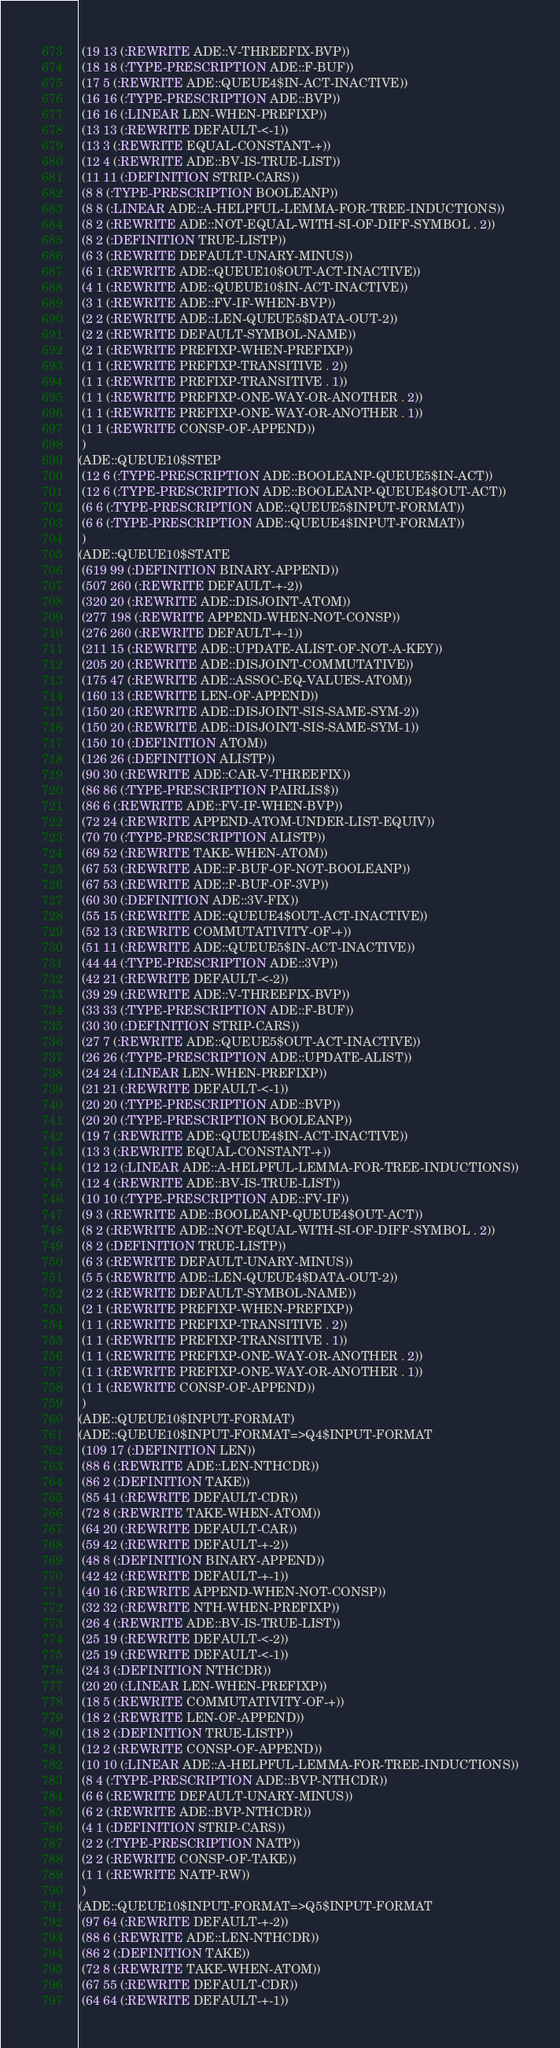Convert code to text. <code><loc_0><loc_0><loc_500><loc_500><_Lisp_> (19 13 (:REWRITE ADE::V-THREEFIX-BVP))
 (18 18 (:TYPE-PRESCRIPTION ADE::F-BUF))
 (17 5 (:REWRITE ADE::QUEUE4$IN-ACT-INACTIVE))
 (16 16 (:TYPE-PRESCRIPTION ADE::BVP))
 (16 16 (:LINEAR LEN-WHEN-PREFIXP))
 (13 13 (:REWRITE DEFAULT-<-1))
 (13 3 (:REWRITE EQUAL-CONSTANT-+))
 (12 4 (:REWRITE ADE::BV-IS-TRUE-LIST))
 (11 11 (:DEFINITION STRIP-CARS))
 (8 8 (:TYPE-PRESCRIPTION BOOLEANP))
 (8 8 (:LINEAR ADE::A-HELPFUL-LEMMA-FOR-TREE-INDUCTIONS))
 (8 2 (:REWRITE ADE::NOT-EQUAL-WITH-SI-OF-DIFF-SYMBOL . 2))
 (8 2 (:DEFINITION TRUE-LISTP))
 (6 3 (:REWRITE DEFAULT-UNARY-MINUS))
 (6 1 (:REWRITE ADE::QUEUE10$OUT-ACT-INACTIVE))
 (4 1 (:REWRITE ADE::QUEUE10$IN-ACT-INACTIVE))
 (3 1 (:REWRITE ADE::FV-IF-WHEN-BVP))
 (2 2 (:REWRITE ADE::LEN-QUEUE5$DATA-OUT-2))
 (2 2 (:REWRITE DEFAULT-SYMBOL-NAME))
 (2 1 (:REWRITE PREFIXP-WHEN-PREFIXP))
 (1 1 (:REWRITE PREFIXP-TRANSITIVE . 2))
 (1 1 (:REWRITE PREFIXP-TRANSITIVE . 1))
 (1 1 (:REWRITE PREFIXP-ONE-WAY-OR-ANOTHER . 2))
 (1 1 (:REWRITE PREFIXP-ONE-WAY-OR-ANOTHER . 1))
 (1 1 (:REWRITE CONSP-OF-APPEND))
 )
(ADE::QUEUE10$STEP
 (12 6 (:TYPE-PRESCRIPTION ADE::BOOLEANP-QUEUE5$IN-ACT))
 (12 6 (:TYPE-PRESCRIPTION ADE::BOOLEANP-QUEUE4$OUT-ACT))
 (6 6 (:TYPE-PRESCRIPTION ADE::QUEUE5$INPUT-FORMAT))
 (6 6 (:TYPE-PRESCRIPTION ADE::QUEUE4$INPUT-FORMAT))
 )
(ADE::QUEUE10$STATE
 (619 99 (:DEFINITION BINARY-APPEND))
 (507 260 (:REWRITE DEFAULT-+-2))
 (320 20 (:REWRITE ADE::DISJOINT-ATOM))
 (277 198 (:REWRITE APPEND-WHEN-NOT-CONSP))
 (276 260 (:REWRITE DEFAULT-+-1))
 (211 15 (:REWRITE ADE::UPDATE-ALIST-OF-NOT-A-KEY))
 (205 20 (:REWRITE ADE::DISJOINT-COMMUTATIVE))
 (175 47 (:REWRITE ADE::ASSOC-EQ-VALUES-ATOM))
 (160 13 (:REWRITE LEN-OF-APPEND))
 (150 20 (:REWRITE ADE::DISJOINT-SIS-SAME-SYM-2))
 (150 20 (:REWRITE ADE::DISJOINT-SIS-SAME-SYM-1))
 (150 10 (:DEFINITION ATOM))
 (126 26 (:DEFINITION ALISTP))
 (90 30 (:REWRITE ADE::CAR-V-THREEFIX))
 (86 86 (:TYPE-PRESCRIPTION PAIRLIS$))
 (86 6 (:REWRITE ADE::FV-IF-WHEN-BVP))
 (72 24 (:REWRITE APPEND-ATOM-UNDER-LIST-EQUIV))
 (70 70 (:TYPE-PRESCRIPTION ALISTP))
 (69 52 (:REWRITE TAKE-WHEN-ATOM))
 (67 53 (:REWRITE ADE::F-BUF-OF-NOT-BOOLEANP))
 (67 53 (:REWRITE ADE::F-BUF-OF-3VP))
 (60 30 (:DEFINITION ADE::3V-FIX))
 (55 15 (:REWRITE ADE::QUEUE4$OUT-ACT-INACTIVE))
 (52 13 (:REWRITE COMMUTATIVITY-OF-+))
 (51 11 (:REWRITE ADE::QUEUE5$IN-ACT-INACTIVE))
 (44 44 (:TYPE-PRESCRIPTION ADE::3VP))
 (42 21 (:REWRITE DEFAULT-<-2))
 (39 29 (:REWRITE ADE::V-THREEFIX-BVP))
 (33 33 (:TYPE-PRESCRIPTION ADE::F-BUF))
 (30 30 (:DEFINITION STRIP-CARS))
 (27 7 (:REWRITE ADE::QUEUE5$OUT-ACT-INACTIVE))
 (26 26 (:TYPE-PRESCRIPTION ADE::UPDATE-ALIST))
 (24 24 (:LINEAR LEN-WHEN-PREFIXP))
 (21 21 (:REWRITE DEFAULT-<-1))
 (20 20 (:TYPE-PRESCRIPTION ADE::BVP))
 (20 20 (:TYPE-PRESCRIPTION BOOLEANP))
 (19 7 (:REWRITE ADE::QUEUE4$IN-ACT-INACTIVE))
 (13 3 (:REWRITE EQUAL-CONSTANT-+))
 (12 12 (:LINEAR ADE::A-HELPFUL-LEMMA-FOR-TREE-INDUCTIONS))
 (12 4 (:REWRITE ADE::BV-IS-TRUE-LIST))
 (10 10 (:TYPE-PRESCRIPTION ADE::FV-IF))
 (9 3 (:REWRITE ADE::BOOLEANP-QUEUE4$OUT-ACT))
 (8 2 (:REWRITE ADE::NOT-EQUAL-WITH-SI-OF-DIFF-SYMBOL . 2))
 (8 2 (:DEFINITION TRUE-LISTP))
 (6 3 (:REWRITE DEFAULT-UNARY-MINUS))
 (5 5 (:REWRITE ADE::LEN-QUEUE4$DATA-OUT-2))
 (2 2 (:REWRITE DEFAULT-SYMBOL-NAME))
 (2 1 (:REWRITE PREFIXP-WHEN-PREFIXP))
 (1 1 (:REWRITE PREFIXP-TRANSITIVE . 2))
 (1 1 (:REWRITE PREFIXP-TRANSITIVE . 1))
 (1 1 (:REWRITE PREFIXP-ONE-WAY-OR-ANOTHER . 2))
 (1 1 (:REWRITE PREFIXP-ONE-WAY-OR-ANOTHER . 1))
 (1 1 (:REWRITE CONSP-OF-APPEND))
 )
(ADE::QUEUE10$INPUT-FORMAT)
(ADE::QUEUE10$INPUT-FORMAT=>Q4$INPUT-FORMAT
 (109 17 (:DEFINITION LEN))
 (88 6 (:REWRITE ADE::LEN-NTHCDR))
 (86 2 (:DEFINITION TAKE))
 (85 41 (:REWRITE DEFAULT-CDR))
 (72 8 (:REWRITE TAKE-WHEN-ATOM))
 (64 20 (:REWRITE DEFAULT-CAR))
 (59 42 (:REWRITE DEFAULT-+-2))
 (48 8 (:DEFINITION BINARY-APPEND))
 (42 42 (:REWRITE DEFAULT-+-1))
 (40 16 (:REWRITE APPEND-WHEN-NOT-CONSP))
 (32 32 (:REWRITE NTH-WHEN-PREFIXP))
 (26 4 (:REWRITE ADE::BV-IS-TRUE-LIST))
 (25 19 (:REWRITE DEFAULT-<-2))
 (25 19 (:REWRITE DEFAULT-<-1))
 (24 3 (:DEFINITION NTHCDR))
 (20 20 (:LINEAR LEN-WHEN-PREFIXP))
 (18 5 (:REWRITE COMMUTATIVITY-OF-+))
 (18 2 (:REWRITE LEN-OF-APPEND))
 (18 2 (:DEFINITION TRUE-LISTP))
 (12 2 (:REWRITE CONSP-OF-APPEND))
 (10 10 (:LINEAR ADE::A-HELPFUL-LEMMA-FOR-TREE-INDUCTIONS))
 (8 4 (:TYPE-PRESCRIPTION ADE::BVP-NTHCDR))
 (6 6 (:REWRITE DEFAULT-UNARY-MINUS))
 (6 2 (:REWRITE ADE::BVP-NTHCDR))
 (4 1 (:DEFINITION STRIP-CARS))
 (2 2 (:TYPE-PRESCRIPTION NATP))
 (2 2 (:REWRITE CONSP-OF-TAKE))
 (1 1 (:REWRITE NATP-RW))
 )
(ADE::QUEUE10$INPUT-FORMAT=>Q5$INPUT-FORMAT
 (97 64 (:REWRITE DEFAULT-+-2))
 (88 6 (:REWRITE ADE::LEN-NTHCDR))
 (86 2 (:DEFINITION TAKE))
 (72 8 (:REWRITE TAKE-WHEN-ATOM))
 (67 55 (:REWRITE DEFAULT-CDR))
 (64 64 (:REWRITE DEFAULT-+-1))</code> 